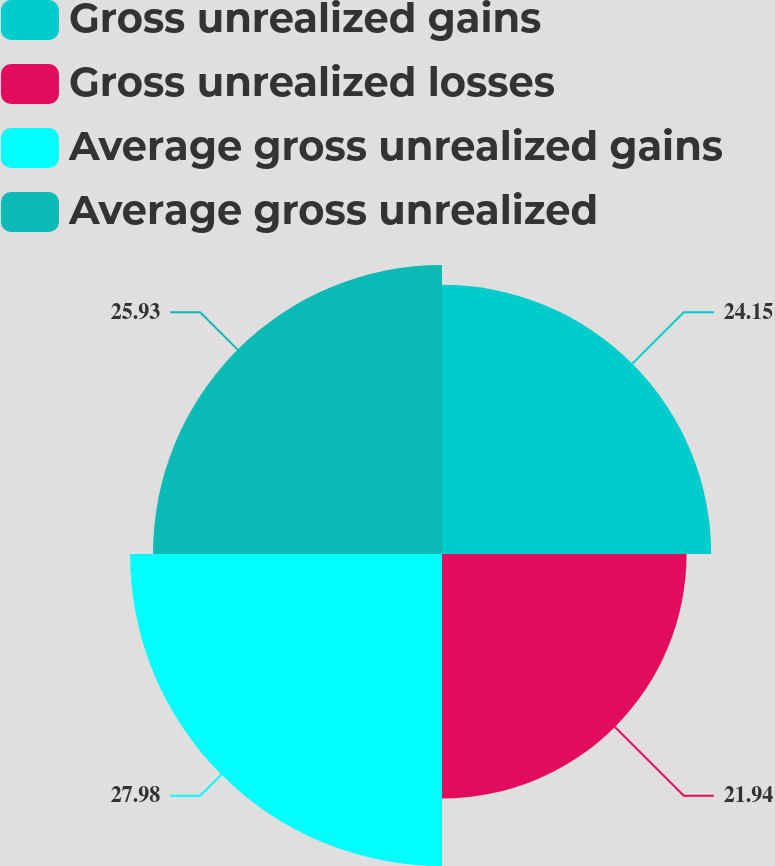Convert chart. <chart><loc_0><loc_0><loc_500><loc_500><pie_chart><fcel>Gross unrealized gains<fcel>Gross unrealized losses<fcel>Average gross unrealized gains<fcel>Average gross unrealized<nl><fcel>24.15%<fcel>21.94%<fcel>27.99%<fcel>25.93%<nl></chart> 